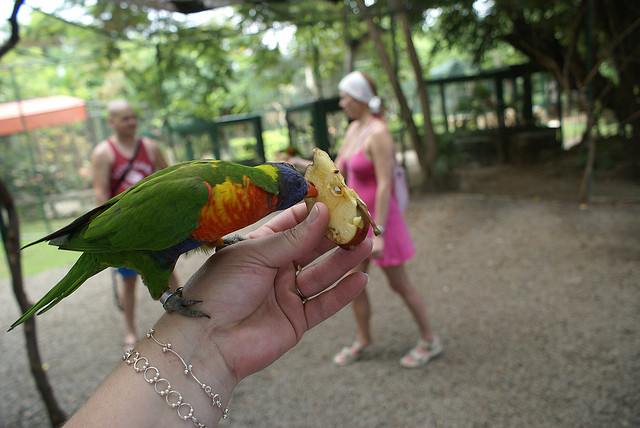<image>What color is the watchband? I don't know the color of the watchband. It can be silver, white, or gold. What color is the watchband? The watchband is silver in color. However, there is no watch band in the image. 